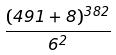Convert formula to latex. <formula><loc_0><loc_0><loc_500><loc_500>\frac { ( 4 9 1 + 8 ) ^ { 3 8 2 } } { 6 ^ { 2 } }</formula> 